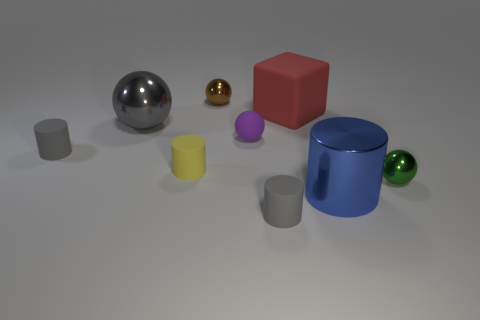How many metallic spheres are behind the green shiny thing?
Provide a succinct answer. 2. Do the small matte ball and the block have the same color?
Your answer should be very brief. No. What is the shape of the small yellow object that is the same material as the cube?
Provide a short and direct response. Cylinder. Does the tiny object in front of the blue shiny thing have the same shape as the large gray thing?
Provide a short and direct response. No. What number of red objects are either matte spheres or large things?
Provide a short and direct response. 1. Are there the same number of blue shiny cylinders on the right side of the green thing and small gray things that are in front of the purple thing?
Provide a short and direct response. No. There is a metallic sphere in front of the metal ball that is to the left of the small brown object that is to the right of the gray ball; what is its color?
Make the answer very short. Green. Are there any other things that have the same color as the large shiny ball?
Provide a succinct answer. Yes. There is a gray cylinder left of the small purple object; what is its size?
Your response must be concise. Small. What shape is the yellow rubber object that is the same size as the green thing?
Your response must be concise. Cylinder. 